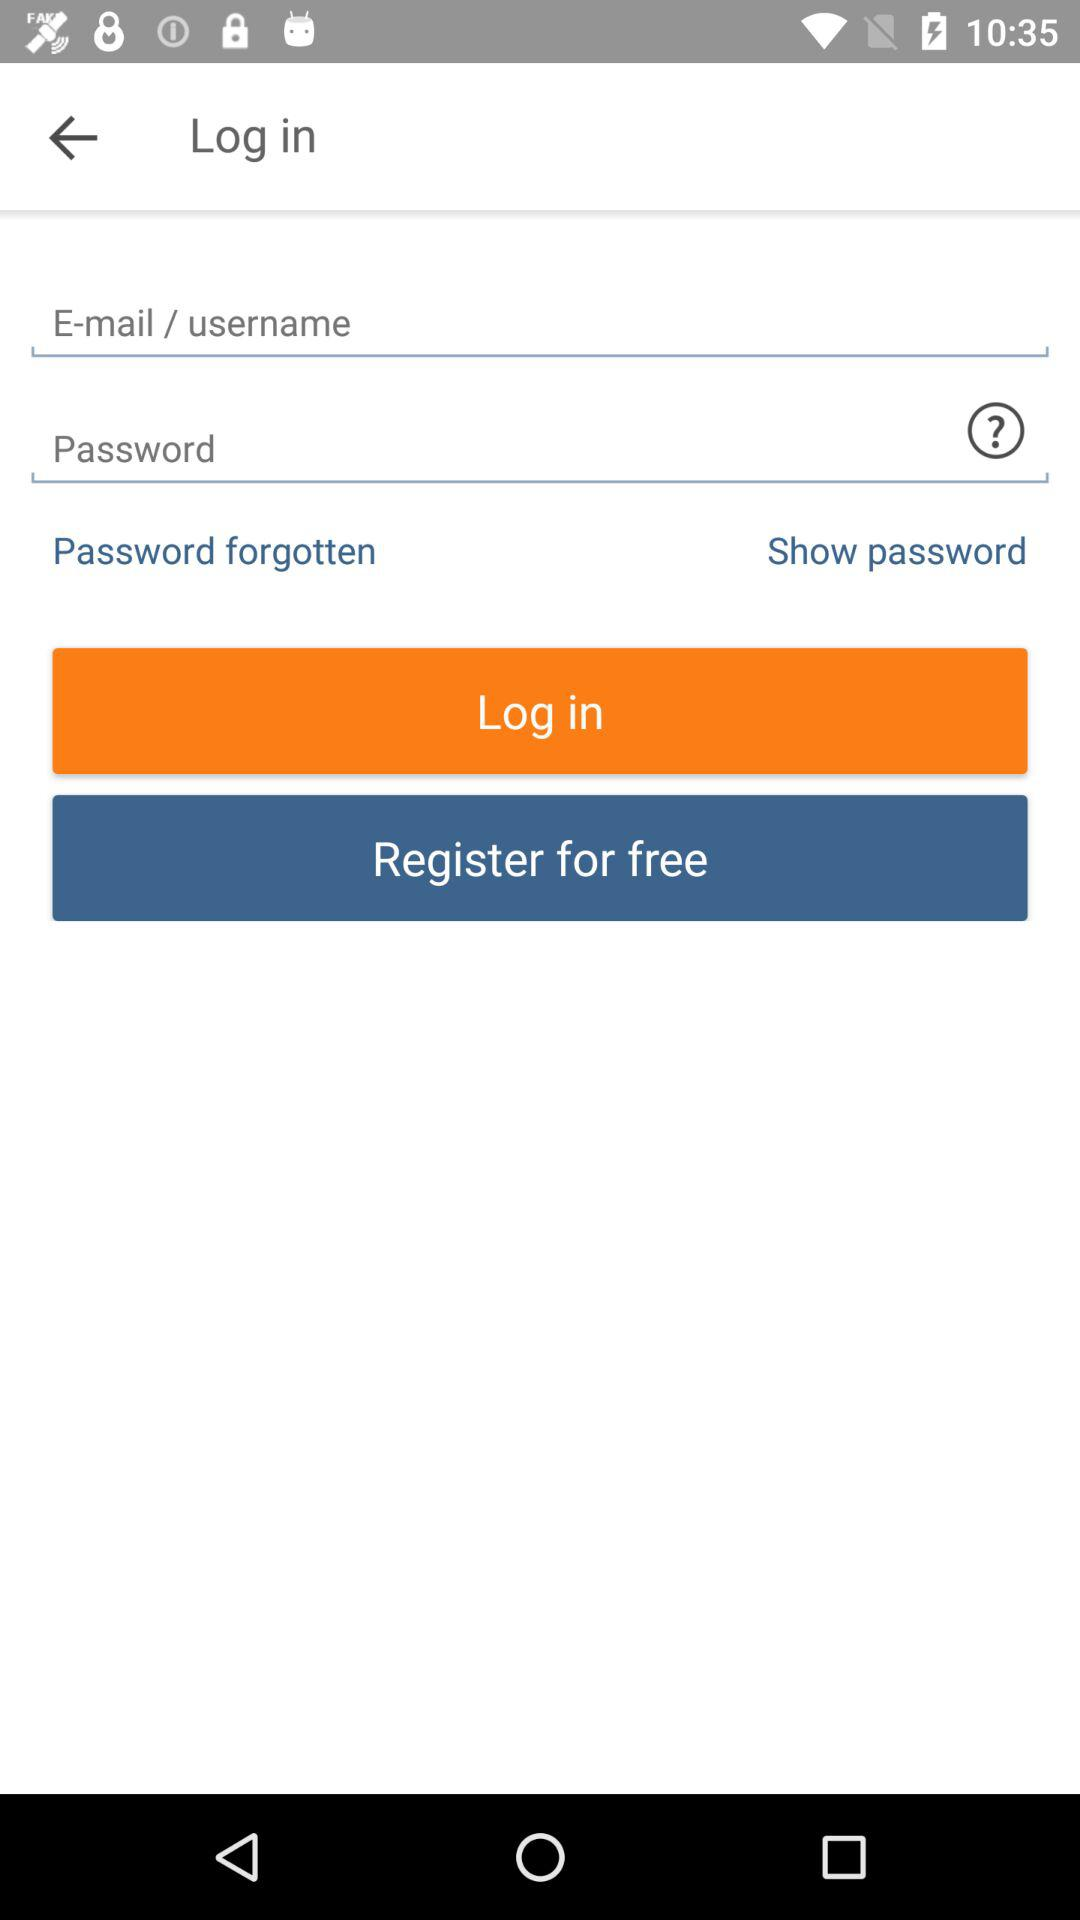How many text input fields are there on the screen?
Answer the question using a single word or phrase. 2 